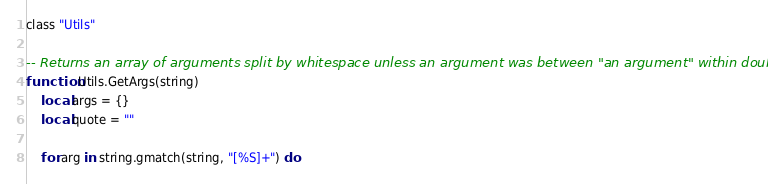<code> <loc_0><loc_0><loc_500><loc_500><_Lua_>class "Utils"

-- Returns an array of arguments split by whitespace unless an argument was between "an argument" within double-quotes
function Utils.GetArgs(string)
	local args = {}
	local quote = ""

	for arg in string.gmatch(string, "[%S]+") do</code> 